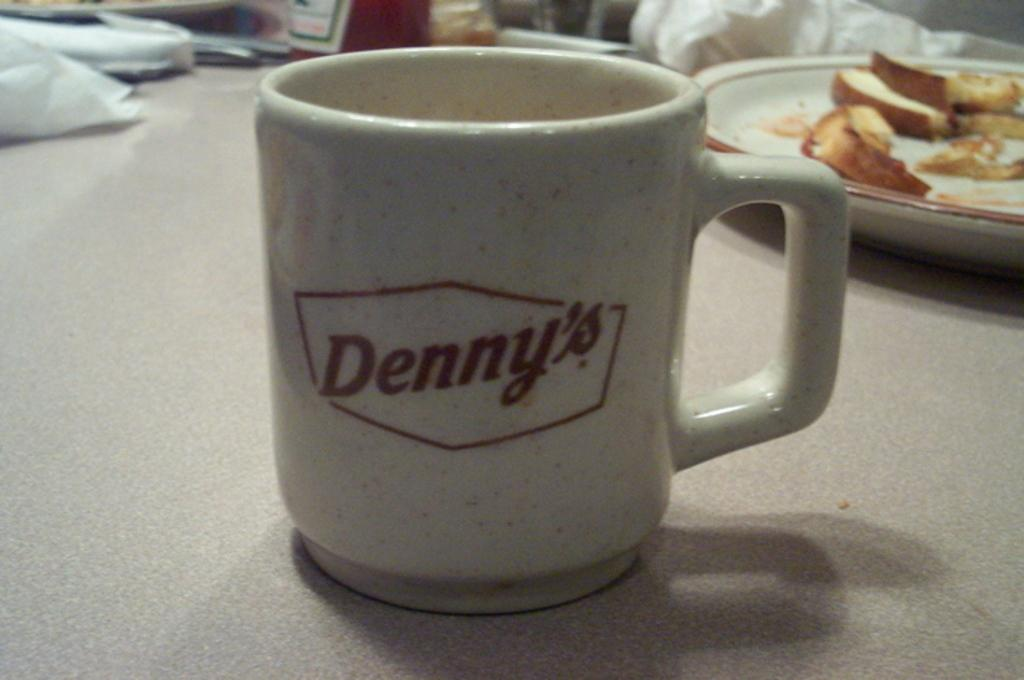<image>
Relay a brief, clear account of the picture shown. A coffee cup that says Denny's sitting on a table next to a plate of leftovers. 